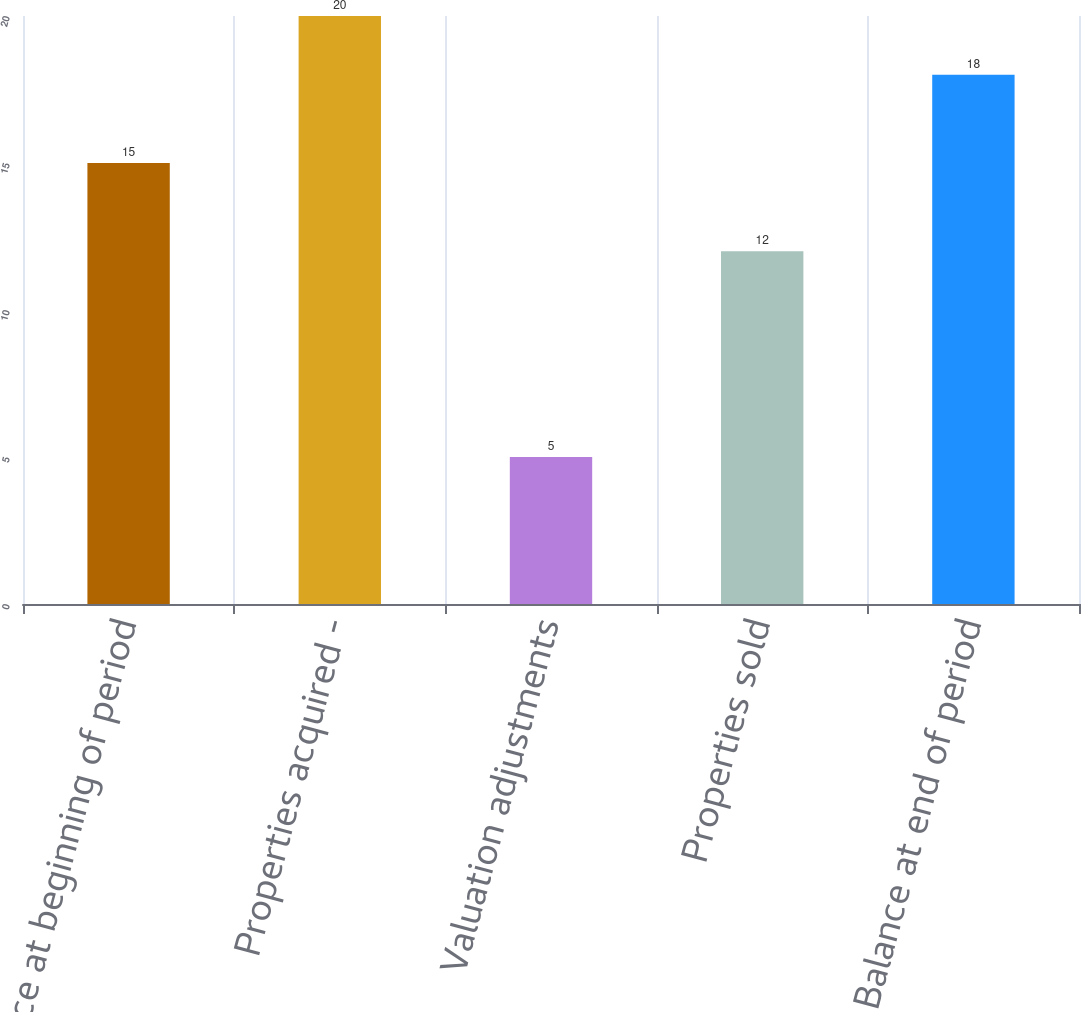Convert chart to OTSL. <chart><loc_0><loc_0><loc_500><loc_500><bar_chart><fcel>Balance at beginning of period<fcel>Properties acquired -<fcel>Valuation adjustments<fcel>Properties sold<fcel>Balance at end of period<nl><fcel>15<fcel>20<fcel>5<fcel>12<fcel>18<nl></chart> 